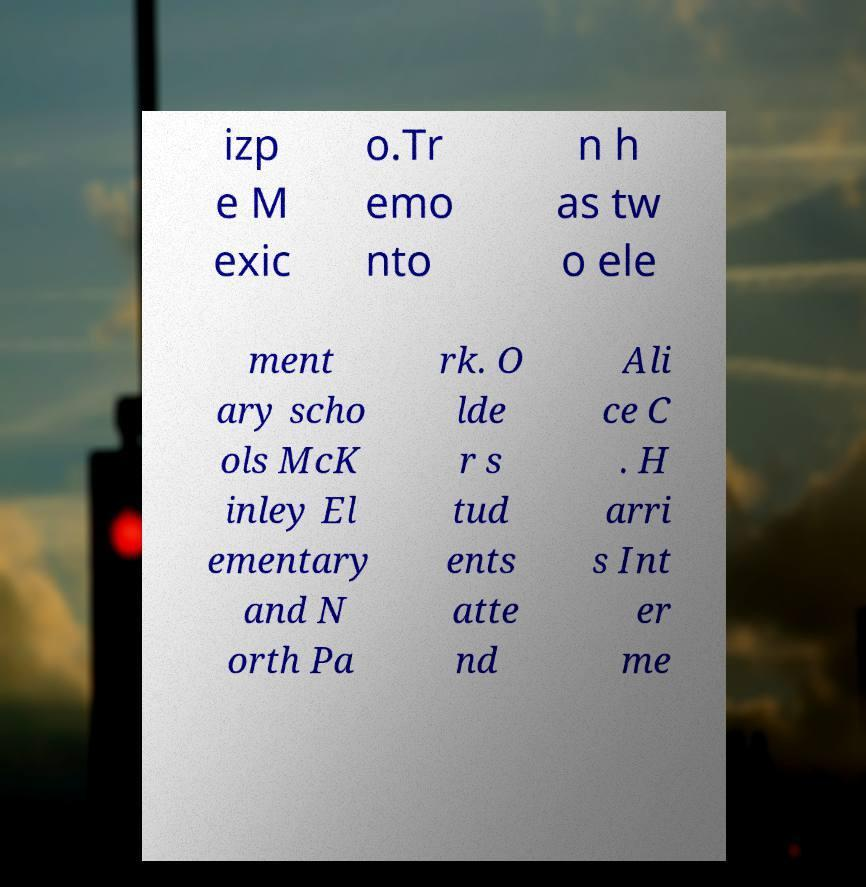Can you accurately transcribe the text from the provided image for me? izp e M exic o.Tr emo nto n h as tw o ele ment ary scho ols McK inley El ementary and N orth Pa rk. O lde r s tud ents atte nd Ali ce C . H arri s Int er me 